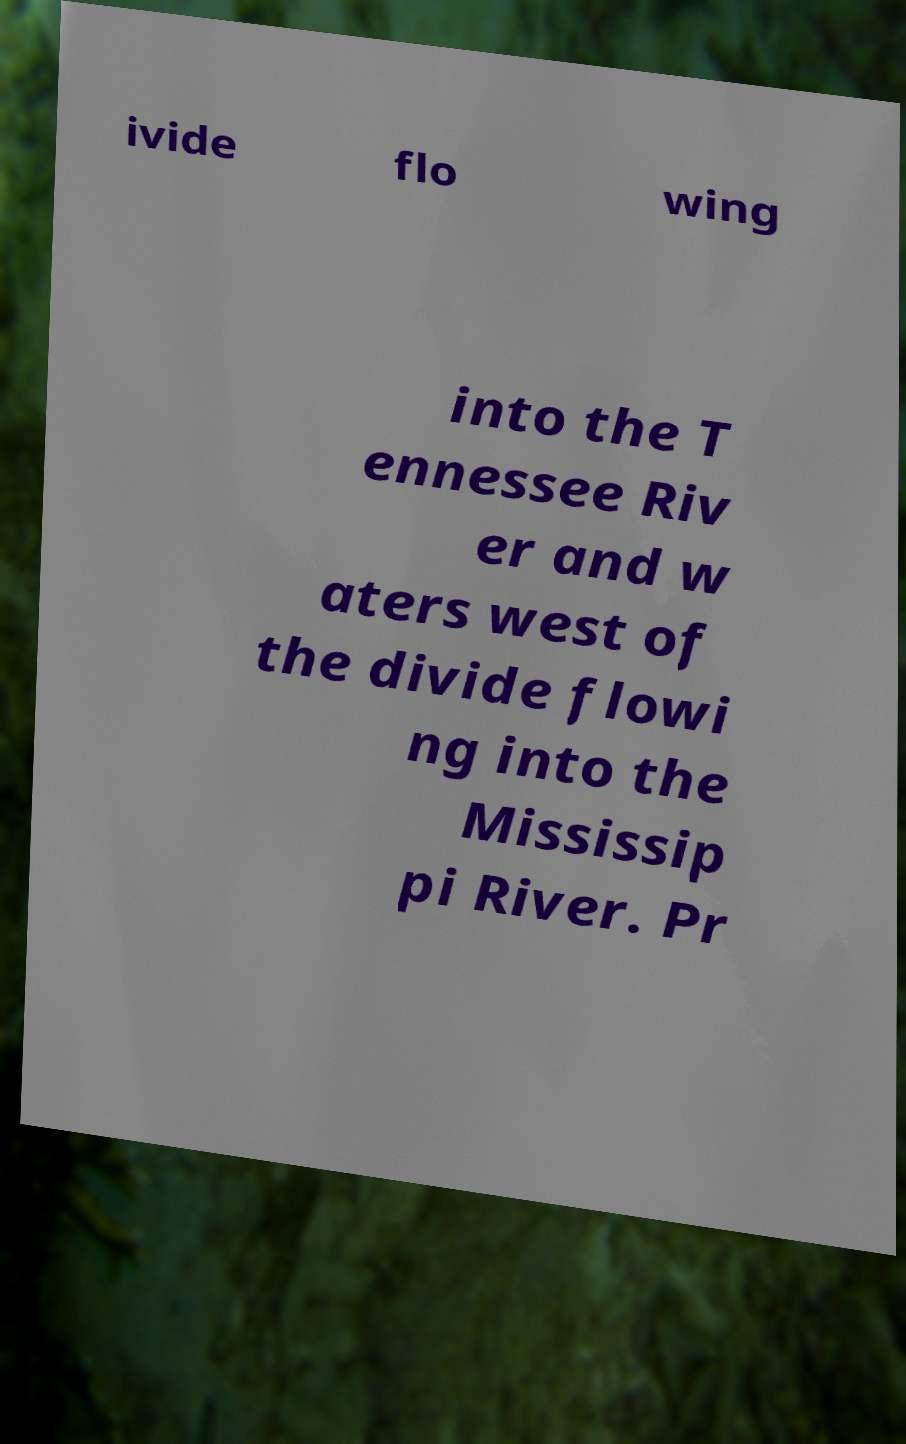Can you accurately transcribe the text from the provided image for me? ivide flo wing into the T ennessee Riv er and w aters west of the divide flowi ng into the Mississip pi River. Pr 